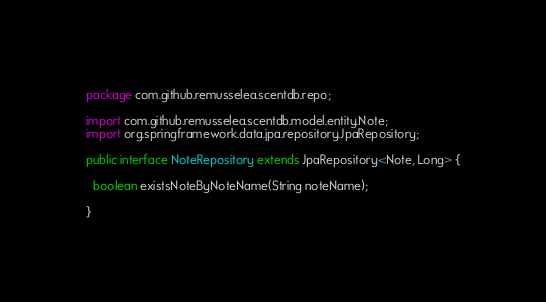Convert code to text. <code><loc_0><loc_0><loc_500><loc_500><_Java_>package com.github.remusselea.scentdb.repo;

import com.github.remusselea.scentdb.model.entity.Note;
import org.springframework.data.jpa.repository.JpaRepository;

public interface NoteRepository extends JpaRepository<Note, Long> {

  boolean existsNoteByNoteName(String noteName);

}
</code> 